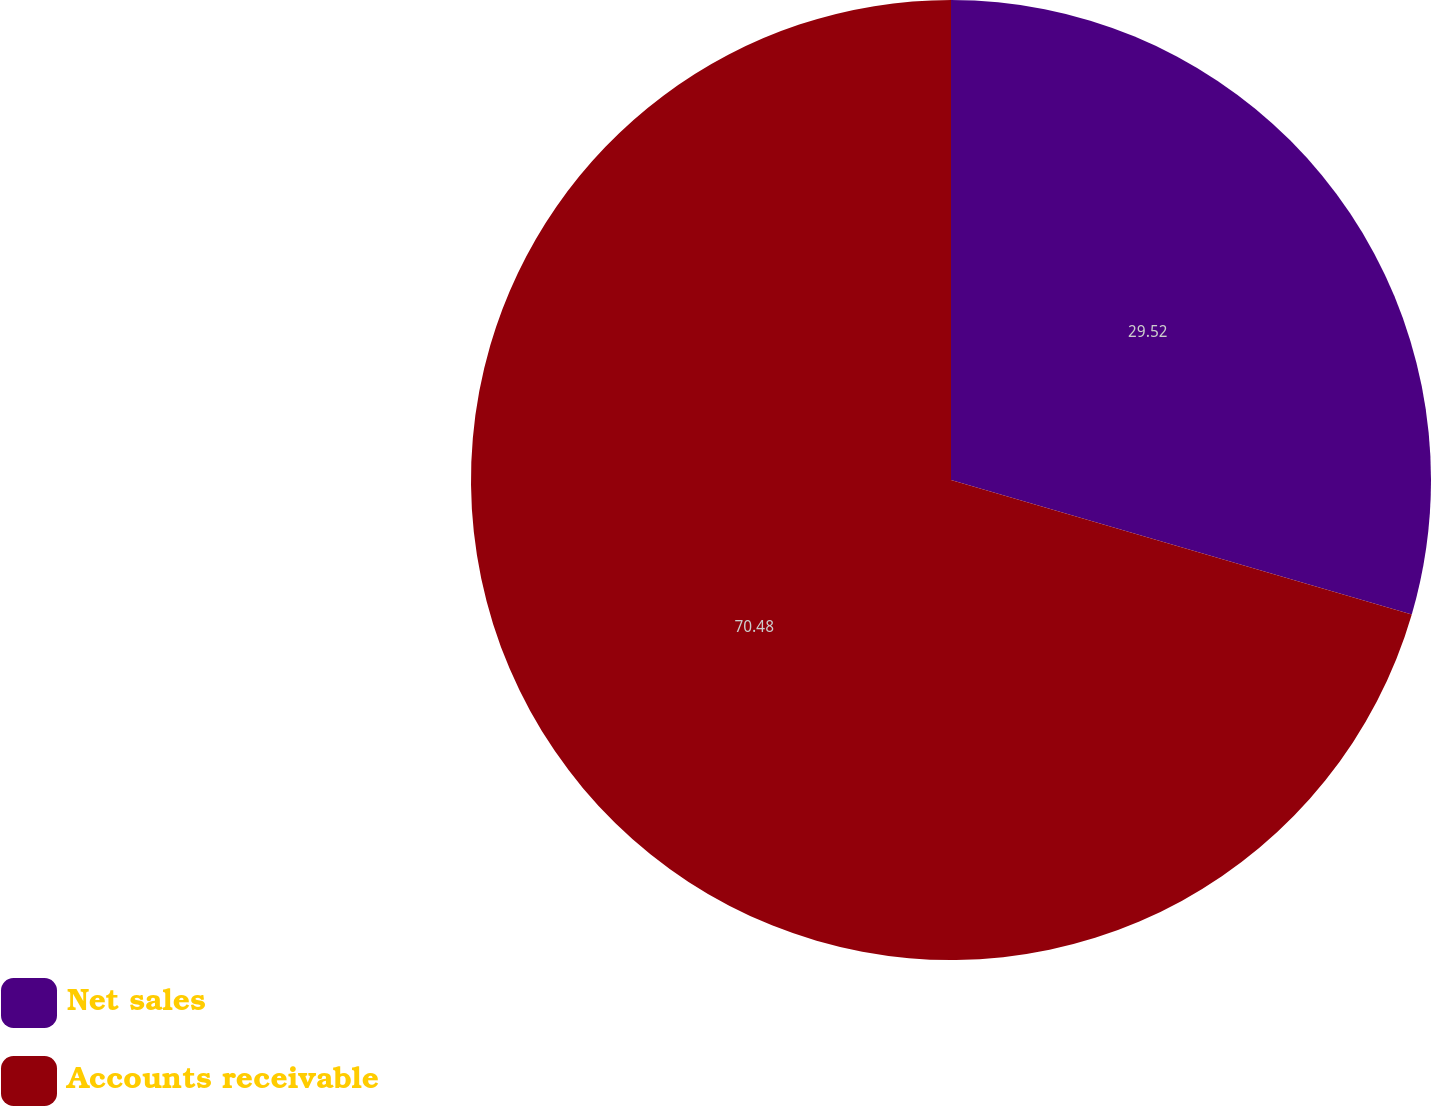Convert chart. <chart><loc_0><loc_0><loc_500><loc_500><pie_chart><fcel>Net sales<fcel>Accounts receivable<nl><fcel>29.52%<fcel>70.48%<nl></chart> 